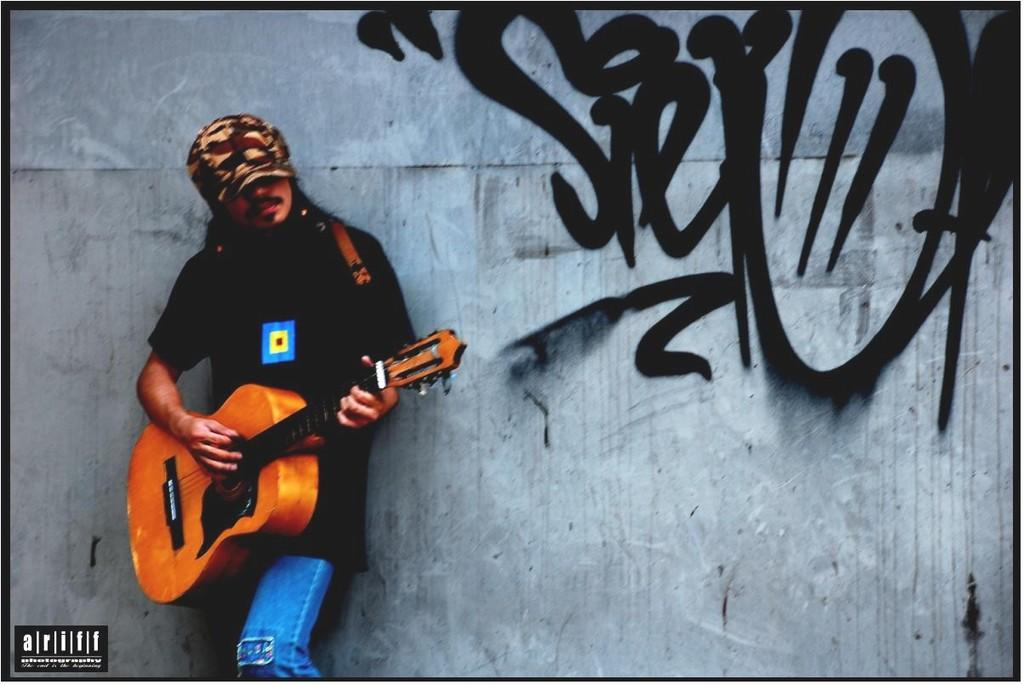What is the main subject of the image? There is a person in the image. What is the person wearing on their head? The person is wearing a hat. What color is the shirt the person is wearing? The person is wearing a black shirt. What type of pants is the person wearing? The person is wearing blue jeans. What object is the person holding in the image? The person is holding a guitar. What can be seen in the background of the image? There is a wall in the background of the image. What type of thrill can be seen on the person's face in the image? There is no indication of a thrill or emotion on the person's face in the image. Can you provide a list of all the items the person is holding in the image? The person is only holding a guitar in the image. 